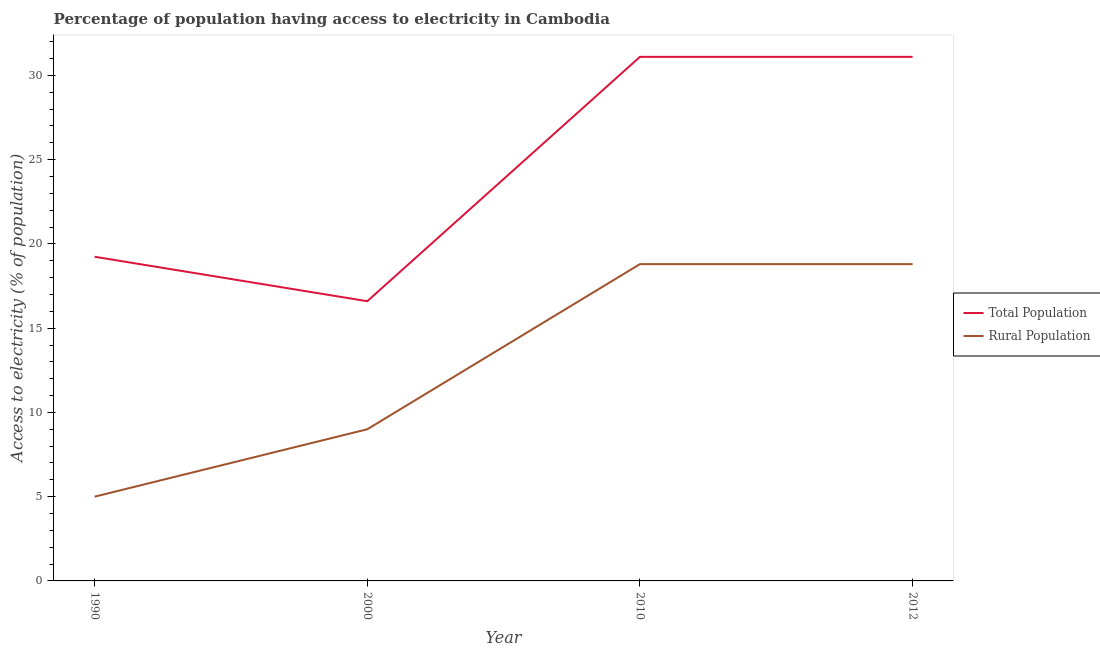Does the line corresponding to percentage of population having access to electricity intersect with the line corresponding to percentage of rural population having access to electricity?
Ensure brevity in your answer.  No. Is the number of lines equal to the number of legend labels?
Offer a terse response. Yes. Across all years, what is the maximum percentage of population having access to electricity?
Offer a terse response. 31.1. Across all years, what is the minimum percentage of rural population having access to electricity?
Your answer should be compact. 5. In which year was the percentage of rural population having access to electricity maximum?
Provide a succinct answer. 2010. In which year was the percentage of rural population having access to electricity minimum?
Ensure brevity in your answer.  1990. What is the total percentage of rural population having access to electricity in the graph?
Give a very brief answer. 51.6. What is the difference between the percentage of rural population having access to electricity in 2010 and the percentage of population having access to electricity in 2000?
Give a very brief answer. 2.2. What is the average percentage of population having access to electricity per year?
Make the answer very short. 24.51. In the year 1990, what is the difference between the percentage of rural population having access to electricity and percentage of population having access to electricity?
Provide a short and direct response. -14.24. In how many years, is the percentage of population having access to electricity greater than 30 %?
Your answer should be compact. 2. What is the ratio of the percentage of population having access to electricity in 2000 to that in 2010?
Provide a short and direct response. 0.53. What is the difference between the highest and the lowest percentage of rural population having access to electricity?
Ensure brevity in your answer.  13.8. In how many years, is the percentage of population having access to electricity greater than the average percentage of population having access to electricity taken over all years?
Make the answer very short. 2. Is the sum of the percentage of population having access to electricity in 1990 and 2012 greater than the maximum percentage of rural population having access to electricity across all years?
Your answer should be very brief. Yes. Does the percentage of population having access to electricity monotonically increase over the years?
Your answer should be compact. No. How many years are there in the graph?
Give a very brief answer. 4. Are the values on the major ticks of Y-axis written in scientific E-notation?
Offer a very short reply. No. Does the graph contain any zero values?
Provide a short and direct response. No. Where does the legend appear in the graph?
Ensure brevity in your answer.  Center right. What is the title of the graph?
Offer a very short reply. Percentage of population having access to electricity in Cambodia. Does "Imports" appear as one of the legend labels in the graph?
Offer a terse response. No. What is the label or title of the Y-axis?
Keep it short and to the point. Access to electricity (% of population). What is the Access to electricity (% of population) of Total Population in 1990?
Your answer should be very brief. 19.24. What is the Access to electricity (% of population) in Total Population in 2010?
Your response must be concise. 31.1. What is the Access to electricity (% of population) of Total Population in 2012?
Your answer should be very brief. 31.1. What is the Access to electricity (% of population) in Rural Population in 2012?
Your response must be concise. 18.8. Across all years, what is the maximum Access to electricity (% of population) of Total Population?
Give a very brief answer. 31.1. Across all years, what is the maximum Access to electricity (% of population) in Rural Population?
Provide a succinct answer. 18.8. Across all years, what is the minimum Access to electricity (% of population) in Total Population?
Your response must be concise. 16.6. Across all years, what is the minimum Access to electricity (% of population) in Rural Population?
Keep it short and to the point. 5. What is the total Access to electricity (% of population) in Total Population in the graph?
Provide a succinct answer. 98.04. What is the total Access to electricity (% of population) in Rural Population in the graph?
Make the answer very short. 51.6. What is the difference between the Access to electricity (% of population) of Total Population in 1990 and that in 2000?
Provide a succinct answer. 2.64. What is the difference between the Access to electricity (% of population) in Total Population in 1990 and that in 2010?
Provide a short and direct response. -11.86. What is the difference between the Access to electricity (% of population) in Rural Population in 1990 and that in 2010?
Your answer should be very brief. -13.8. What is the difference between the Access to electricity (% of population) in Total Population in 1990 and that in 2012?
Provide a succinct answer. -11.86. What is the difference between the Access to electricity (% of population) of Rural Population in 1990 and that in 2012?
Provide a short and direct response. -13.8. What is the difference between the Access to electricity (% of population) of Rural Population in 2000 and that in 2010?
Your response must be concise. -9.8. What is the difference between the Access to electricity (% of population) of Rural Population in 2000 and that in 2012?
Keep it short and to the point. -9.8. What is the difference between the Access to electricity (% of population) in Total Population in 2010 and that in 2012?
Provide a short and direct response. 0. What is the difference between the Access to electricity (% of population) of Total Population in 1990 and the Access to electricity (% of population) of Rural Population in 2000?
Give a very brief answer. 10.24. What is the difference between the Access to electricity (% of population) in Total Population in 1990 and the Access to electricity (% of population) in Rural Population in 2010?
Give a very brief answer. 0.44. What is the difference between the Access to electricity (% of population) in Total Population in 1990 and the Access to electricity (% of population) in Rural Population in 2012?
Your answer should be very brief. 0.44. What is the average Access to electricity (% of population) of Total Population per year?
Make the answer very short. 24.51. In the year 1990, what is the difference between the Access to electricity (% of population) in Total Population and Access to electricity (% of population) in Rural Population?
Your answer should be compact. 14.24. In the year 2000, what is the difference between the Access to electricity (% of population) in Total Population and Access to electricity (% of population) in Rural Population?
Offer a very short reply. 7.6. What is the ratio of the Access to electricity (% of population) of Total Population in 1990 to that in 2000?
Your answer should be compact. 1.16. What is the ratio of the Access to electricity (% of population) in Rural Population in 1990 to that in 2000?
Offer a terse response. 0.56. What is the ratio of the Access to electricity (% of population) of Total Population in 1990 to that in 2010?
Give a very brief answer. 0.62. What is the ratio of the Access to electricity (% of population) in Rural Population in 1990 to that in 2010?
Your response must be concise. 0.27. What is the ratio of the Access to electricity (% of population) in Total Population in 1990 to that in 2012?
Your answer should be very brief. 0.62. What is the ratio of the Access to electricity (% of population) of Rural Population in 1990 to that in 2012?
Your answer should be very brief. 0.27. What is the ratio of the Access to electricity (% of population) in Total Population in 2000 to that in 2010?
Your answer should be very brief. 0.53. What is the ratio of the Access to electricity (% of population) in Rural Population in 2000 to that in 2010?
Offer a terse response. 0.48. What is the ratio of the Access to electricity (% of population) in Total Population in 2000 to that in 2012?
Your answer should be very brief. 0.53. What is the ratio of the Access to electricity (% of population) of Rural Population in 2000 to that in 2012?
Provide a short and direct response. 0.48. What is the ratio of the Access to electricity (% of population) in Total Population in 2010 to that in 2012?
Make the answer very short. 1. What is the ratio of the Access to electricity (% of population) in Rural Population in 2010 to that in 2012?
Your answer should be compact. 1. What is the difference between the highest and the lowest Access to electricity (% of population) in Total Population?
Your answer should be very brief. 14.5. 